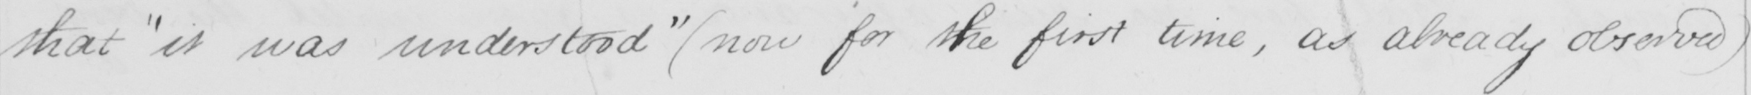Please provide the text content of this handwritten line. that  " it was understood "   ( now for the first time , as already observed ) 